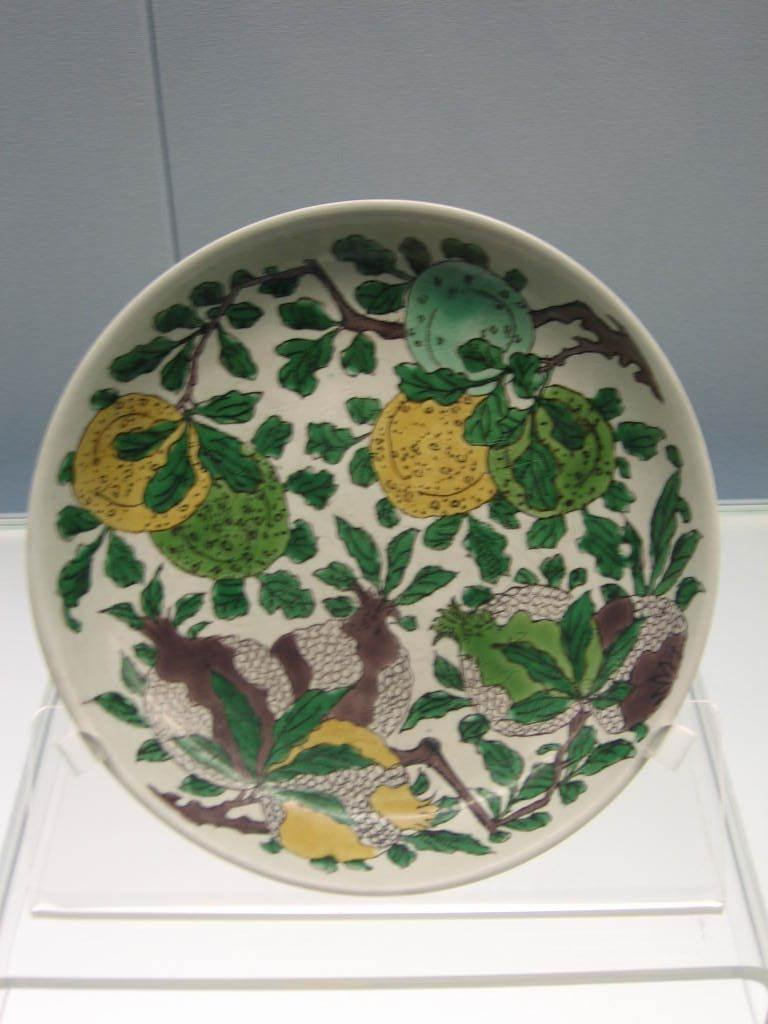What is present on the plate in the image? The plate has a design on it. Where is the plate located in the image? The plate is on a surface. What can be seen in the background of the image? There is a wall in the background of the image. What type of drug is being used by the masked achiever in the image? There is no drug, mask, or achiever present in the image. 